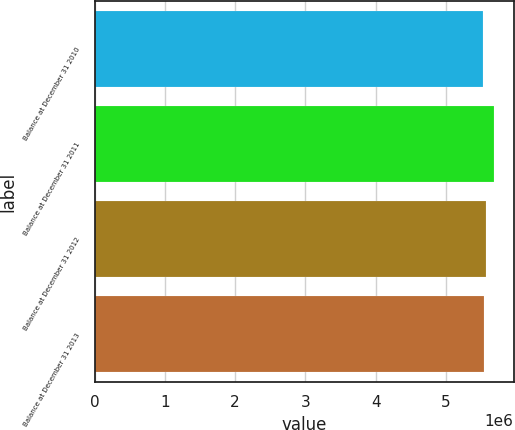<chart> <loc_0><loc_0><loc_500><loc_500><bar_chart><fcel>Balance at December 31 2010<fcel>Balance at December 31 2011<fcel>Balance at December 31 2012<fcel>Balance at December 31 2013<nl><fcel>5.52481e+06<fcel>5.68047e+06<fcel>5.57482e+06<fcel>5.54038e+06<nl></chart> 